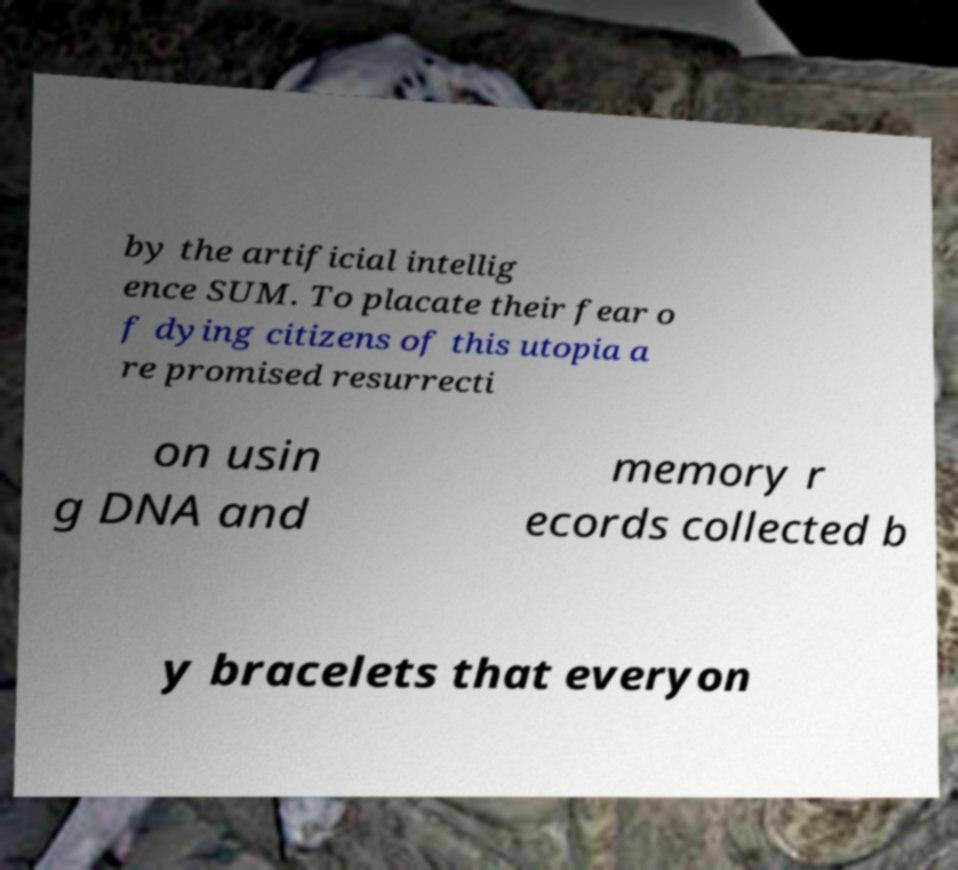For documentation purposes, I need the text within this image transcribed. Could you provide that? by the artificial intellig ence SUM. To placate their fear o f dying citizens of this utopia a re promised resurrecti on usin g DNA and memory r ecords collected b y bracelets that everyon 